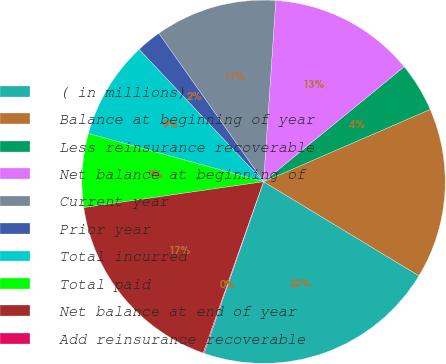Convert chart to OTSL. <chart><loc_0><loc_0><loc_500><loc_500><pie_chart><fcel>( in millions)<fcel>Balance at beginning of year<fcel>Less reinsurance recoverable<fcel>Net balance at beginning of<fcel>Current year<fcel>Prior year<fcel>Total incurred<fcel>Total paid<fcel>Net balance at end of year<fcel>Add reinsurance recoverable<nl><fcel>21.65%<fcel>15.18%<fcel>4.39%<fcel>13.02%<fcel>10.86%<fcel>2.23%<fcel>8.71%<fcel>6.55%<fcel>17.34%<fcel>0.08%<nl></chart> 